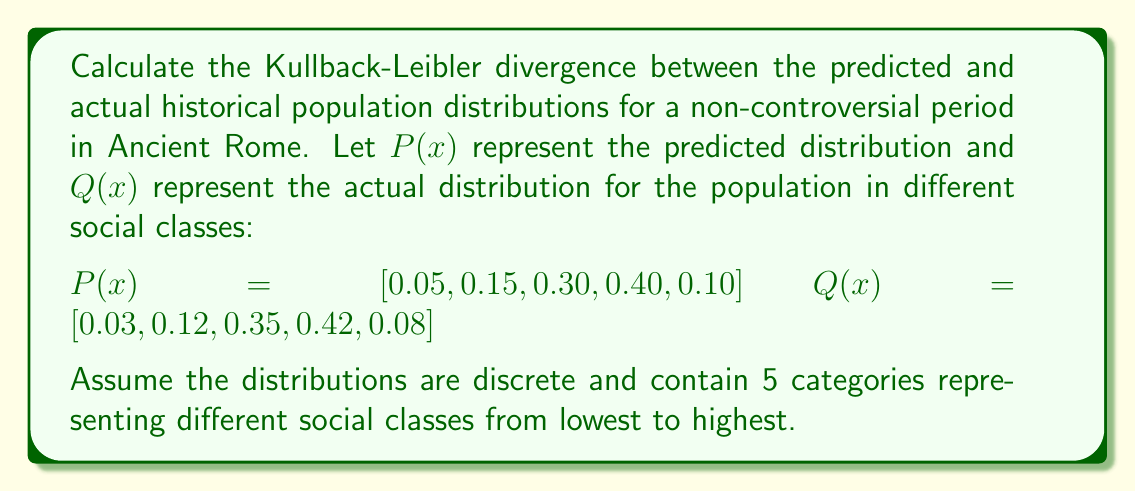Give your solution to this math problem. To calculate the Kullback-Leibler divergence between two discrete probability distributions P and Q, we use the formula:

$$ D_{KL}(P||Q) = \sum_{i} P(i) \log \left(\frac{P(i)}{Q(i)}\right) $$

Let's calculate this step-by-step:

1) First, we need to calculate $\frac{P(i)}{Q(i)}$ for each category:

   $\frac{0.05}{0.03} = 1.6667$
   $\frac{0.15}{0.12} = 1.25$
   $\frac{0.30}{0.35} = 0.8571$
   $\frac{0.40}{0.42} = 0.9524$
   $\frac{0.10}{0.08} = 1.25$

2) Next, we calculate $\log \left(\frac{P(i)}{Q(i)}\right)$ for each category:

   $\log(1.6667) = 0.5108$
   $\log(1.25) = 0.2231$
   $\log(0.8571) = -0.1542$
   $\log(0.9524) = -0.0488$
   $\log(1.25) = 0.2231$

3) Now, we multiply each result by its corresponding P(i) and sum:

   $0.05 * 0.5108 = 0.0255$
   $0.15 * 0.2231 = 0.0335$
   $0.30 * (-0.1542) = -0.0463$
   $0.40 * (-0.0488) = -0.0195$
   $0.10 * 0.2231 = 0.0223$

4) Sum all these values:

   $0.0255 + 0.0335 - 0.0463 - 0.0195 + 0.0223 = 0.0155$

Therefore, the Kullback-Leibler divergence is approximately 0.0155.
Answer: $D_{KL}(P||Q) \approx 0.0155$ 